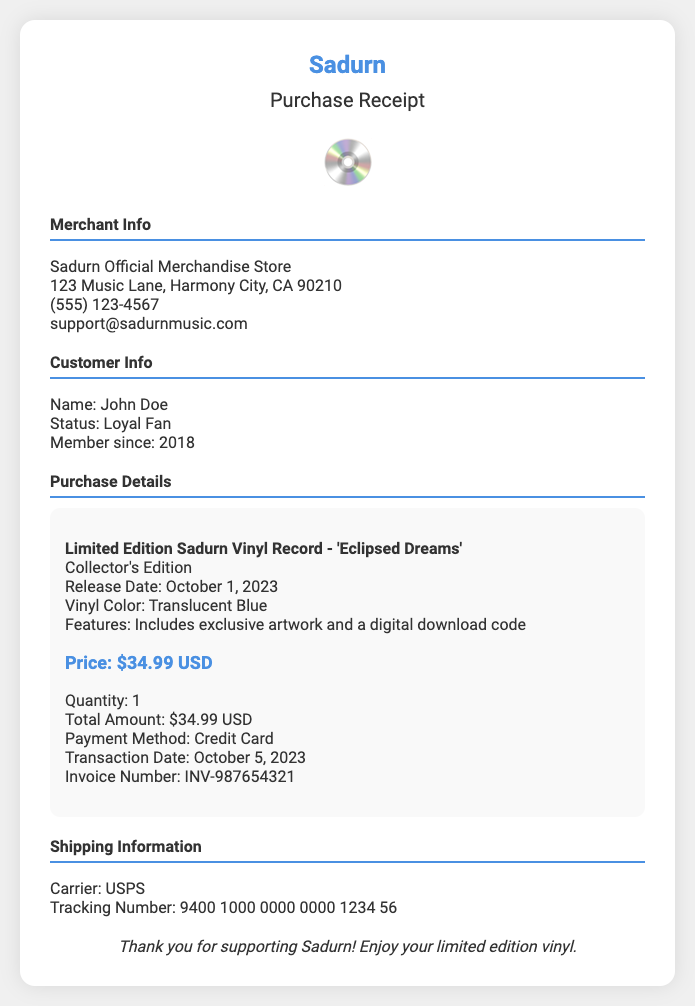What is the item purchased? The purchased item is described as the "Limited Edition Sadurn Vinyl Record - 'Eclipsed Dreams'".
Answer: Limited Edition Sadurn Vinyl Record - 'Eclipsed Dreams' What was the price of the vinyl record? The price listed for the vinyl record is shown in the document as $34.99 USD.
Answer: $34.99 USD What is the payment method used? The document specifies that the payment method used for the transaction was a Credit Card.
Answer: Credit Card When was the transaction date? The transaction date is mentioned in the document and is noted as October 5, 2023.
Answer: October 5, 2023 What color is the vinyl record? The document states that the color of the vinyl record is Translucent Blue.
Answer: Translucent Blue How many vinyl records were purchased? The quantity of vinyl records indicated in the purchase details is 1.
Answer: 1 What is the tracking number for shipping? The document provides the tracking number, which is 9400 1000 0000 0000 1234 56.
Answer: 9400 1000 0000 0000 1234 56 Who is the customer? The customer's name is given in the document as John Doe.
Answer: John Doe What is the invoice number? The invoice number mentioned in the document is INV-987654321.
Answer: INV-987654321 